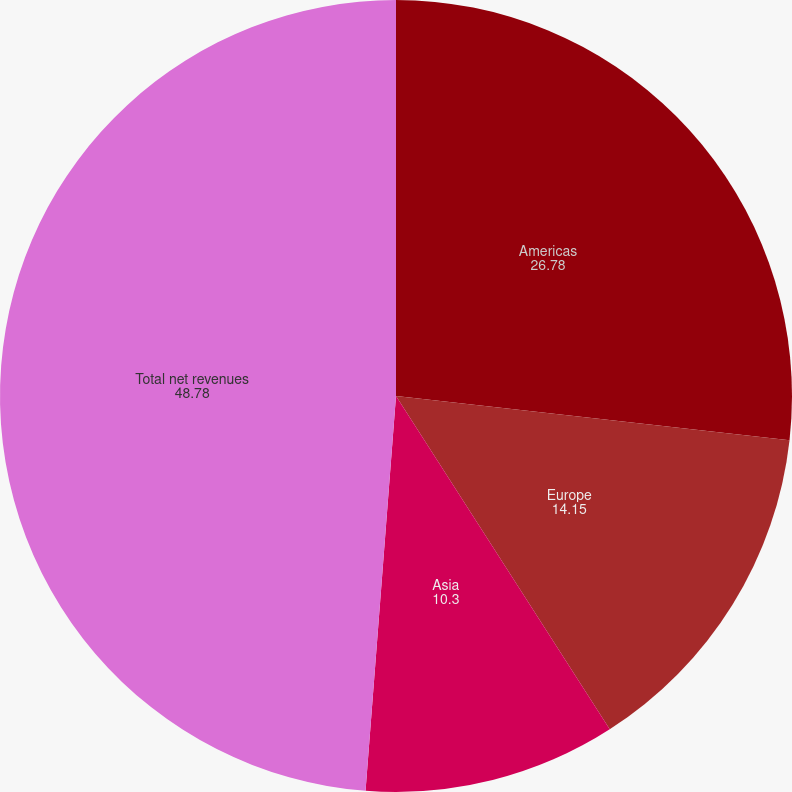Convert chart. <chart><loc_0><loc_0><loc_500><loc_500><pie_chart><fcel>Americas<fcel>Europe<fcel>Asia<fcel>Total net revenues<nl><fcel>26.78%<fcel>14.15%<fcel>10.3%<fcel>48.78%<nl></chart> 